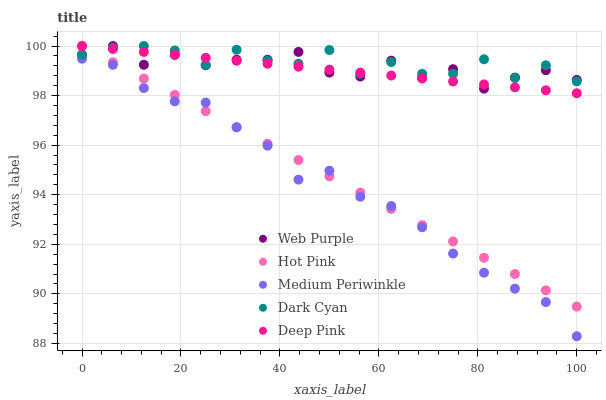Does Medium Periwinkle have the minimum area under the curve?
Answer yes or no. Yes. Does Dark Cyan have the maximum area under the curve?
Answer yes or no. Yes. Does Web Purple have the minimum area under the curve?
Answer yes or no. No. Does Web Purple have the maximum area under the curve?
Answer yes or no. No. Is Hot Pink the smoothest?
Answer yes or no. Yes. Is Dark Cyan the roughest?
Answer yes or no. Yes. Is Web Purple the smoothest?
Answer yes or no. No. Is Web Purple the roughest?
Answer yes or no. No. Does Medium Periwinkle have the lowest value?
Answer yes or no. Yes. Does Web Purple have the lowest value?
Answer yes or no. No. Does Deep Pink have the highest value?
Answer yes or no. Yes. Does Medium Periwinkle have the highest value?
Answer yes or no. No. Is Medium Periwinkle less than Deep Pink?
Answer yes or no. Yes. Is Web Purple greater than Medium Periwinkle?
Answer yes or no. Yes. Does Web Purple intersect Dark Cyan?
Answer yes or no. Yes. Is Web Purple less than Dark Cyan?
Answer yes or no. No. Is Web Purple greater than Dark Cyan?
Answer yes or no. No. Does Medium Periwinkle intersect Deep Pink?
Answer yes or no. No. 